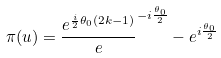<formula> <loc_0><loc_0><loc_500><loc_500>\pi ( u ) = \frac { e ^ { \frac { i } { 2 } \theta _ { 0 } ( 2 k - 1 ) } } e ^ { - i \frac { \theta _ { 0 } } { 2 } } - e ^ { i \frac { \theta _ { 0 } } { 2 } }</formula> 